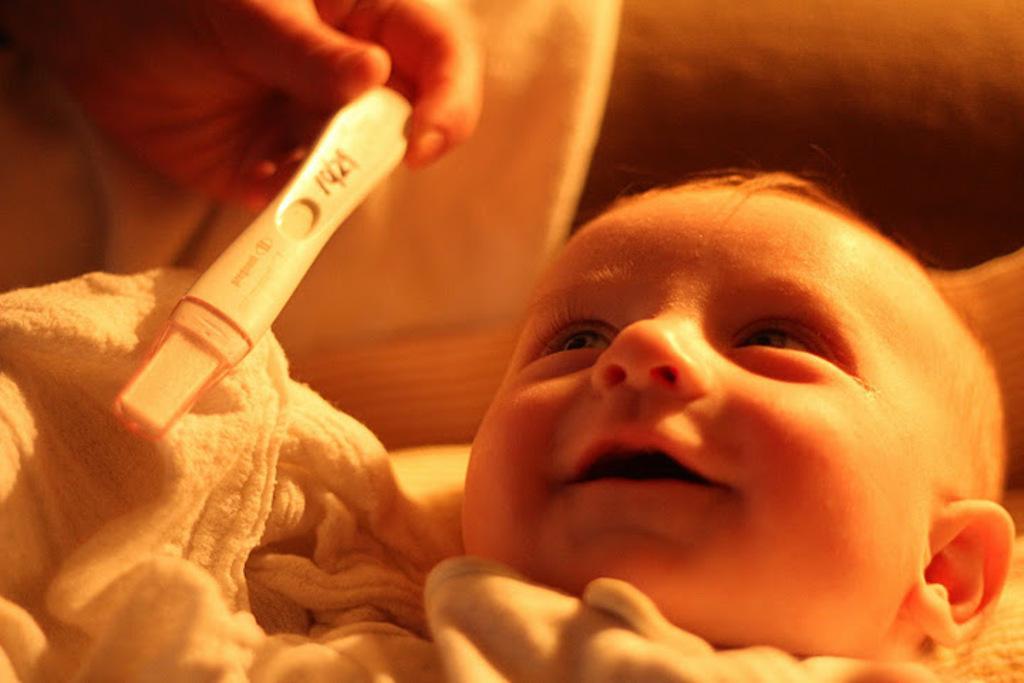Please provide a concise description of this image. There is a small baby, it seems like a towel in the foreground and there is an object in a hand in the top left side. 